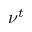<formula> <loc_0><loc_0><loc_500><loc_500>\nu ^ { t }</formula> 